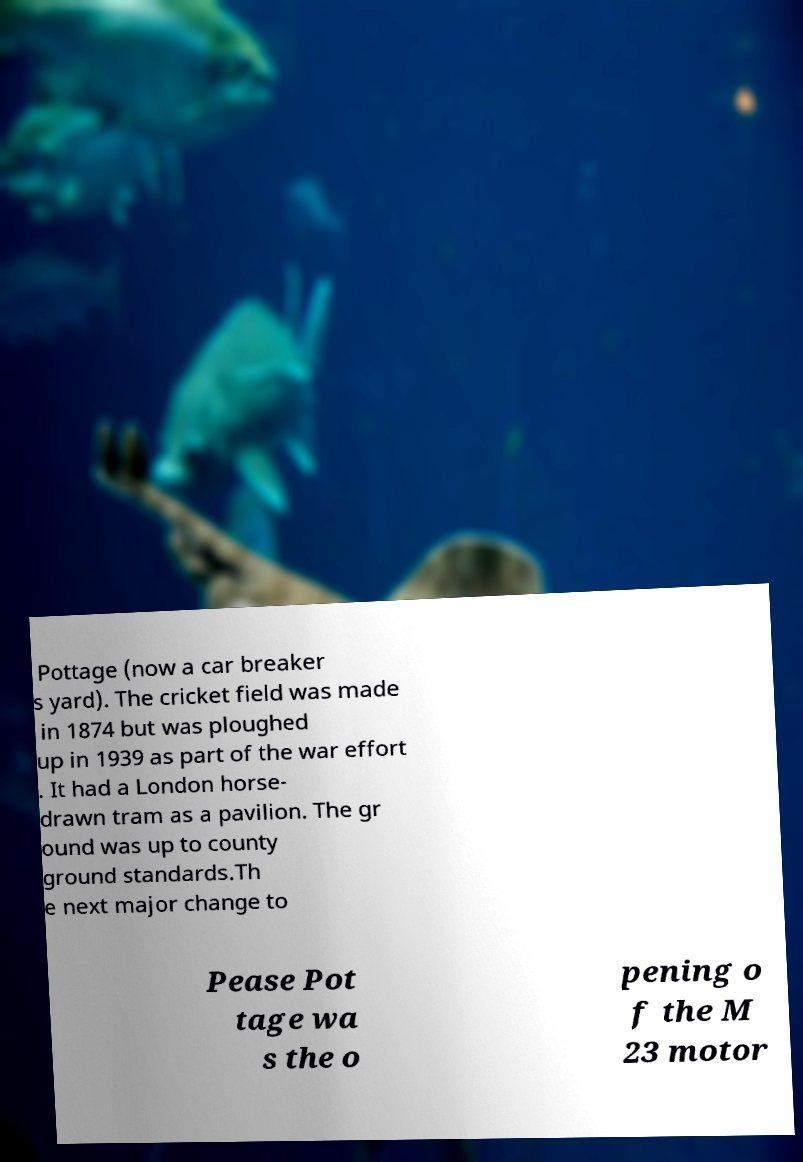I need the written content from this picture converted into text. Can you do that? Pottage (now a car breaker s yard). The cricket field was made in 1874 but was ploughed up in 1939 as part of the war effort . It had a London horse- drawn tram as a pavilion. The gr ound was up to county ground standards.Th e next major change to Pease Pot tage wa s the o pening o f the M 23 motor 